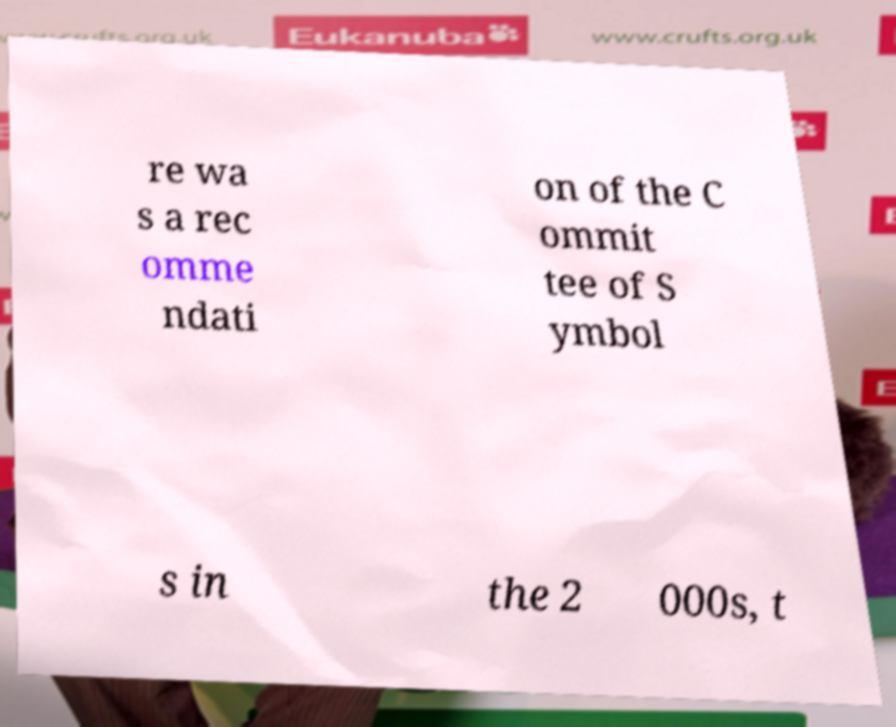Please identify and transcribe the text found in this image. re wa s a rec omme ndati on of the C ommit tee of S ymbol s in the 2 000s, t 